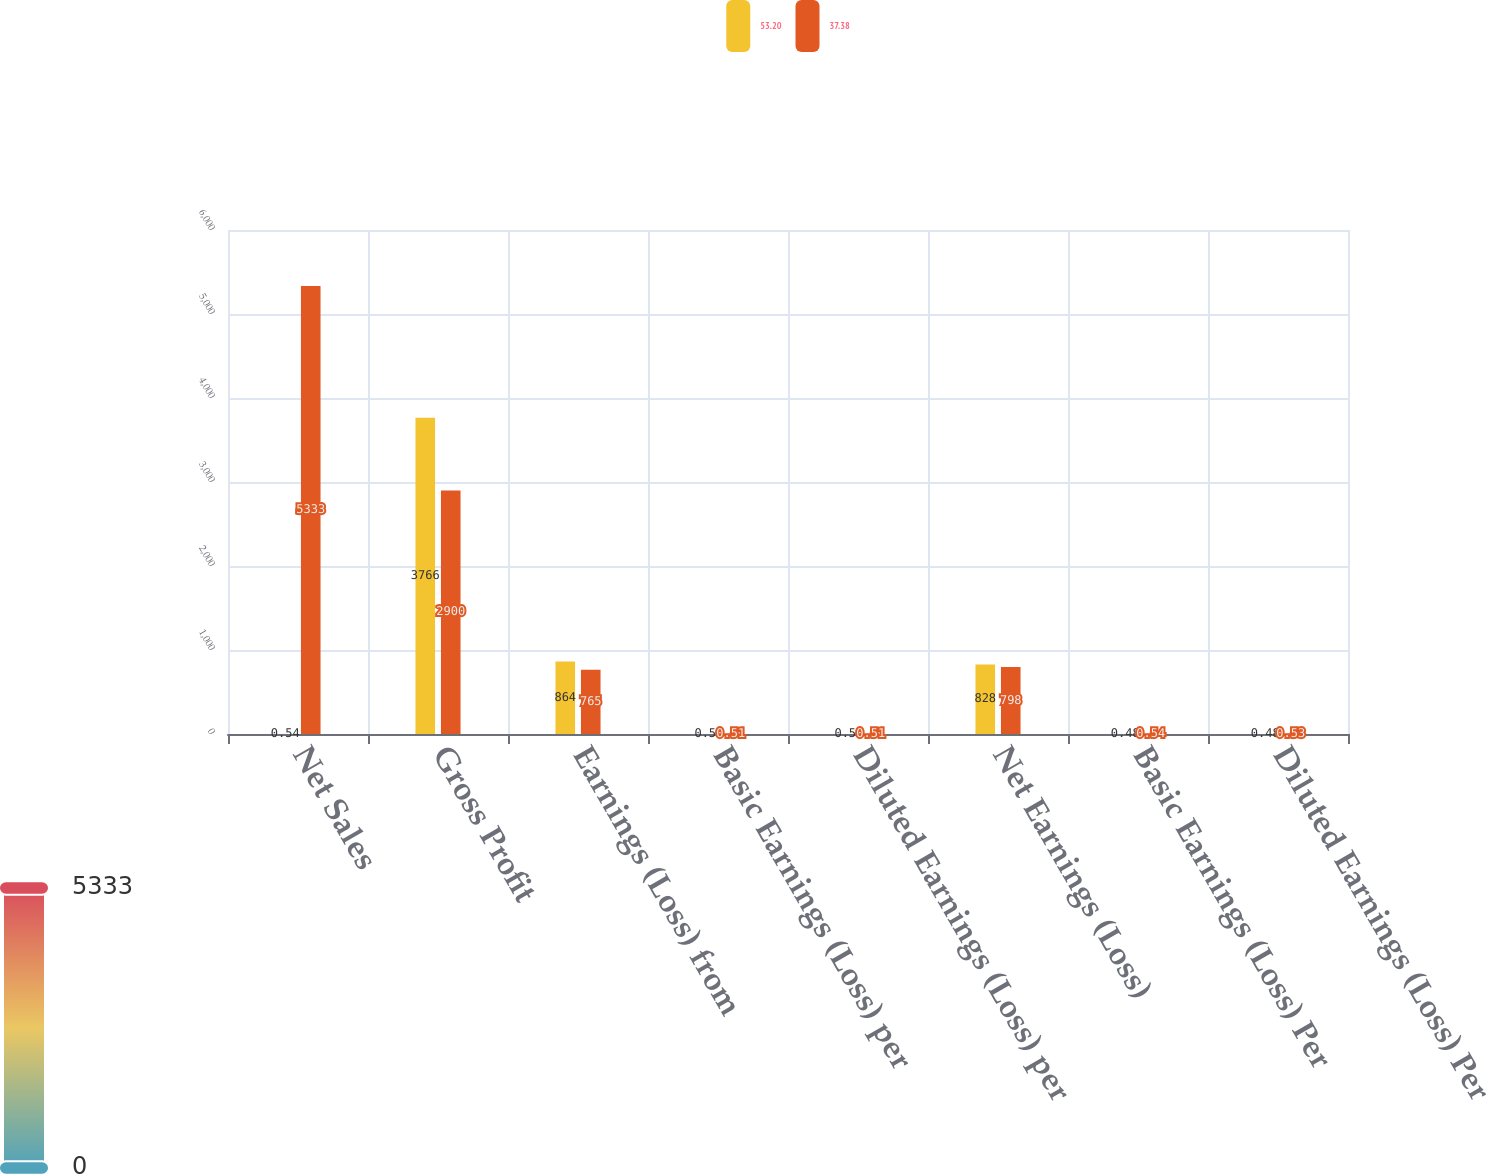<chart> <loc_0><loc_0><loc_500><loc_500><stacked_bar_chart><ecel><fcel>Net Sales<fcel>Gross Profit<fcel>Earnings (Loss) from<fcel>Basic Earnings (Loss) per<fcel>Diluted Earnings (Loss) per<fcel>Net Earnings (Loss)<fcel>Basic Earnings (Loss) Per<fcel>Diluted Earnings (Loss) Per<nl><fcel>53.2<fcel>0.54<fcel>3766<fcel>864<fcel>0.5<fcel>0.5<fcel>828<fcel>0.48<fcel>0.48<nl><fcel>37.38<fcel>5333<fcel>2900<fcel>765<fcel>0.51<fcel>0.51<fcel>798<fcel>0.54<fcel>0.53<nl></chart> 